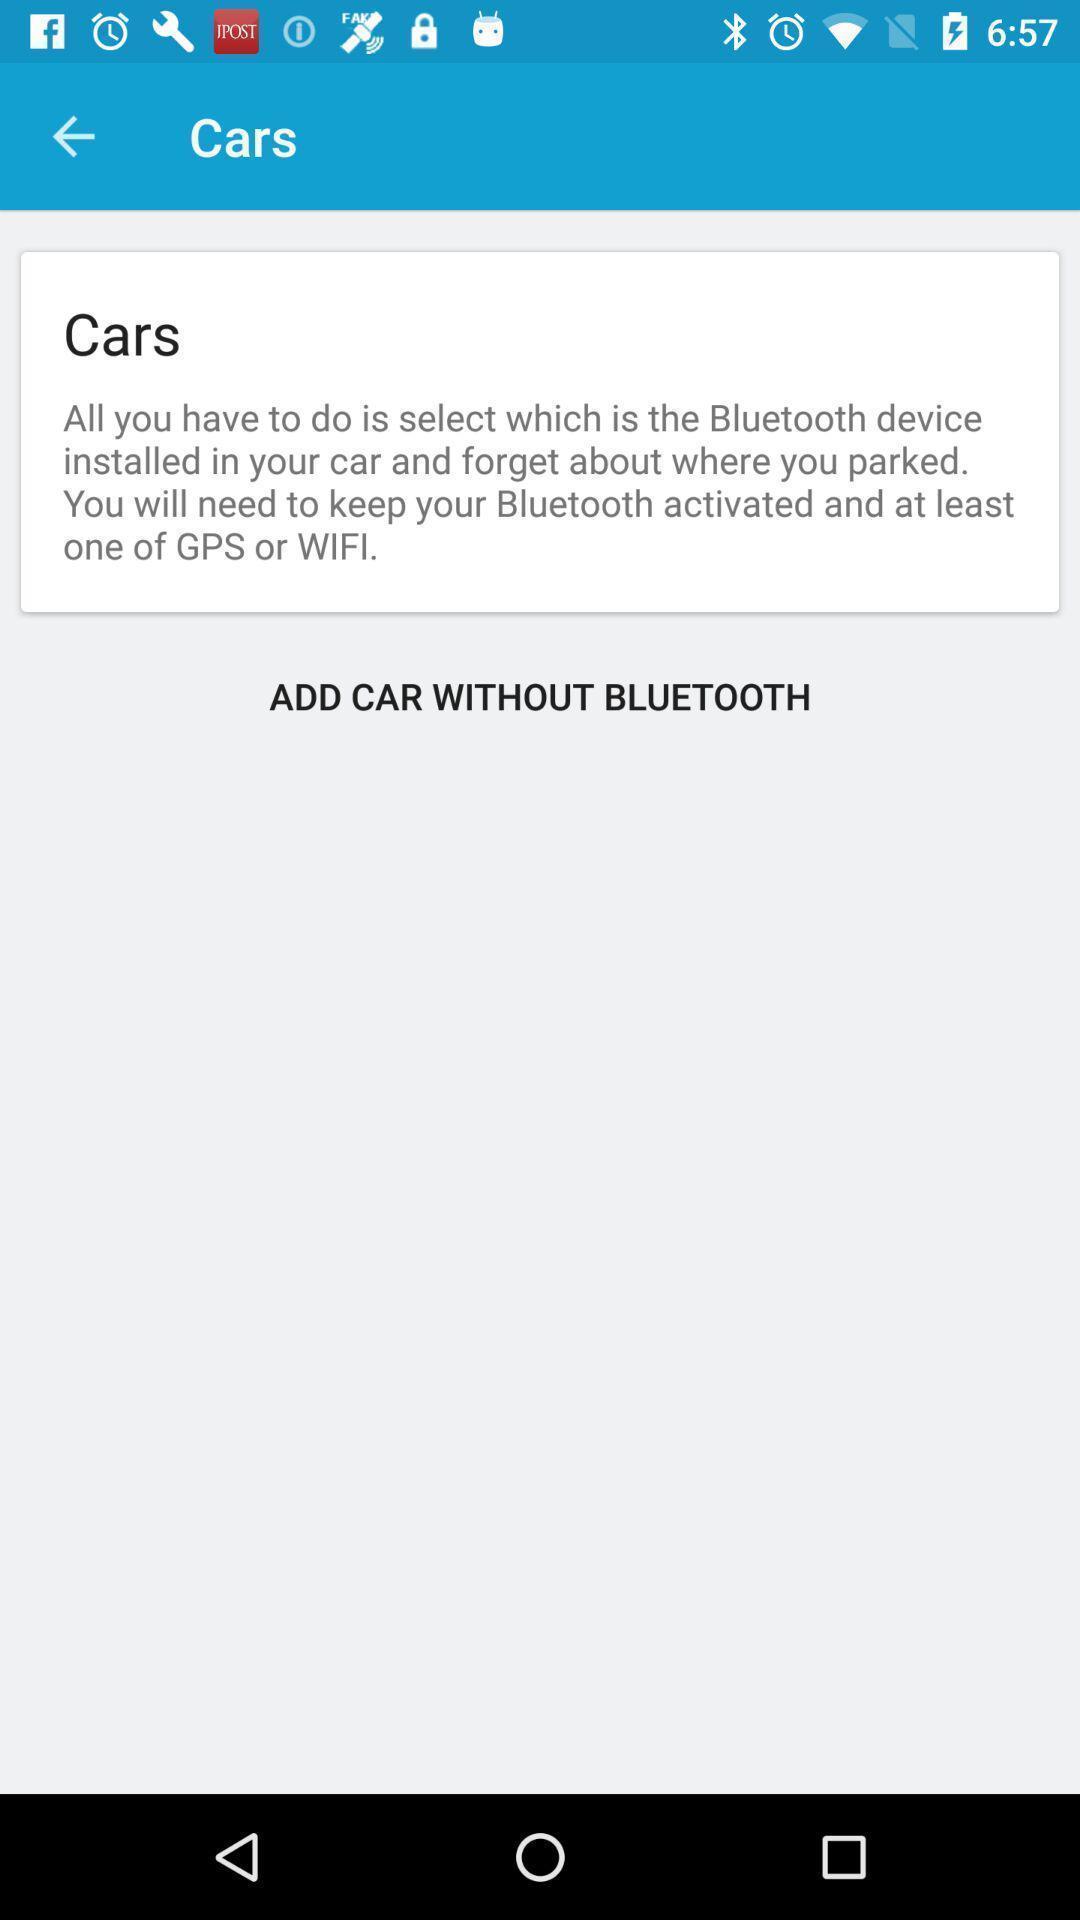Describe the key features of this screenshot. Page for displaying connected cars to blue tooth device. 